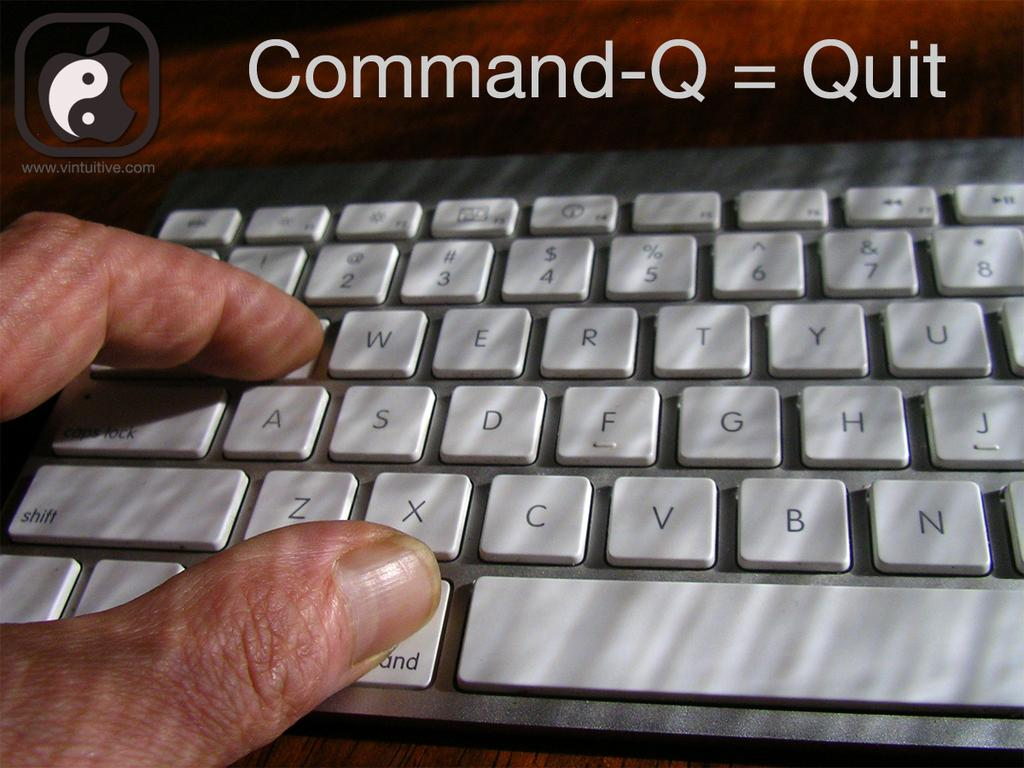<image>
Summarize the visual content of the image. Command-Q = Quit is captioned above this keyboard. 